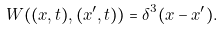<formula> <loc_0><loc_0><loc_500><loc_500>W ( ( { x } , t ) , ( { x } ^ { \prime } , t ) ) = \delta ^ { 3 } ( { x } - { x } ^ { \prime } ) .</formula> 